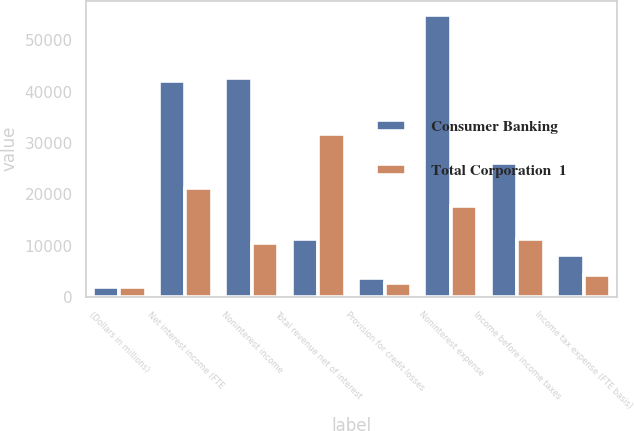<chart> <loc_0><loc_0><loc_500><loc_500><stacked_bar_chart><ecel><fcel>(Dollars in millions)<fcel>Net interest income (FTE<fcel>Noninterest income<fcel>Total revenue net of interest<fcel>Provision for credit losses<fcel>Noninterest expense<fcel>Income before income taxes<fcel>Income tax expense (FTE basis)<nl><fcel>Consumer Banking<fcel>2016<fcel>41996<fcel>42605<fcel>11363<fcel>3597<fcel>54951<fcel>26053<fcel>8147<nl><fcel>Total Corporation  1<fcel>2016<fcel>21290<fcel>10441<fcel>31731<fcel>2715<fcel>17653<fcel>11363<fcel>4190<nl></chart> 